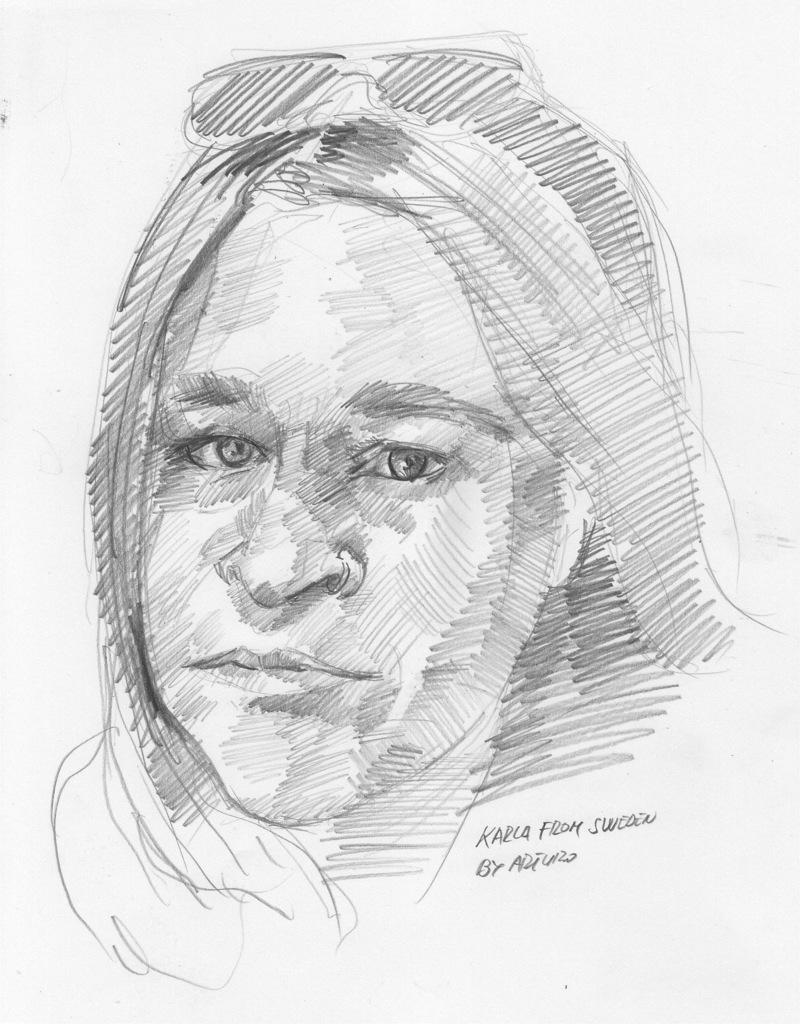What medium was used to create the image? The image is a sketch made with a pencil. What material was the sketch drawn on? The sketch is done on paper. What type of image is this? The image is a sketch. Are there any wrens visible in the sketch? There is no mention of wrens or any other animals in the provided facts, so it cannot be determined if they are present in the sketch. 